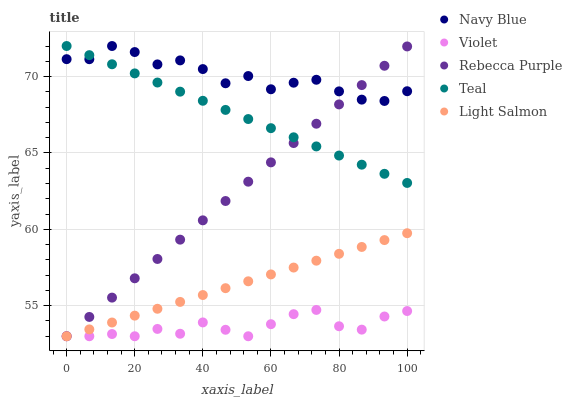Does Violet have the minimum area under the curve?
Answer yes or no. Yes. Does Navy Blue have the maximum area under the curve?
Answer yes or no. Yes. Does Light Salmon have the minimum area under the curve?
Answer yes or no. No. Does Light Salmon have the maximum area under the curve?
Answer yes or no. No. Is Light Salmon the smoothest?
Answer yes or no. Yes. Is Navy Blue the roughest?
Answer yes or no. Yes. Is Rebecca Purple the smoothest?
Answer yes or no. No. Is Rebecca Purple the roughest?
Answer yes or no. No. Does Light Salmon have the lowest value?
Answer yes or no. Yes. Does Teal have the lowest value?
Answer yes or no. No. Does Teal have the highest value?
Answer yes or no. Yes. Does Light Salmon have the highest value?
Answer yes or no. No. Is Light Salmon less than Navy Blue?
Answer yes or no. Yes. Is Navy Blue greater than Light Salmon?
Answer yes or no. Yes. Does Violet intersect Rebecca Purple?
Answer yes or no. Yes. Is Violet less than Rebecca Purple?
Answer yes or no. No. Is Violet greater than Rebecca Purple?
Answer yes or no. No. Does Light Salmon intersect Navy Blue?
Answer yes or no. No. 